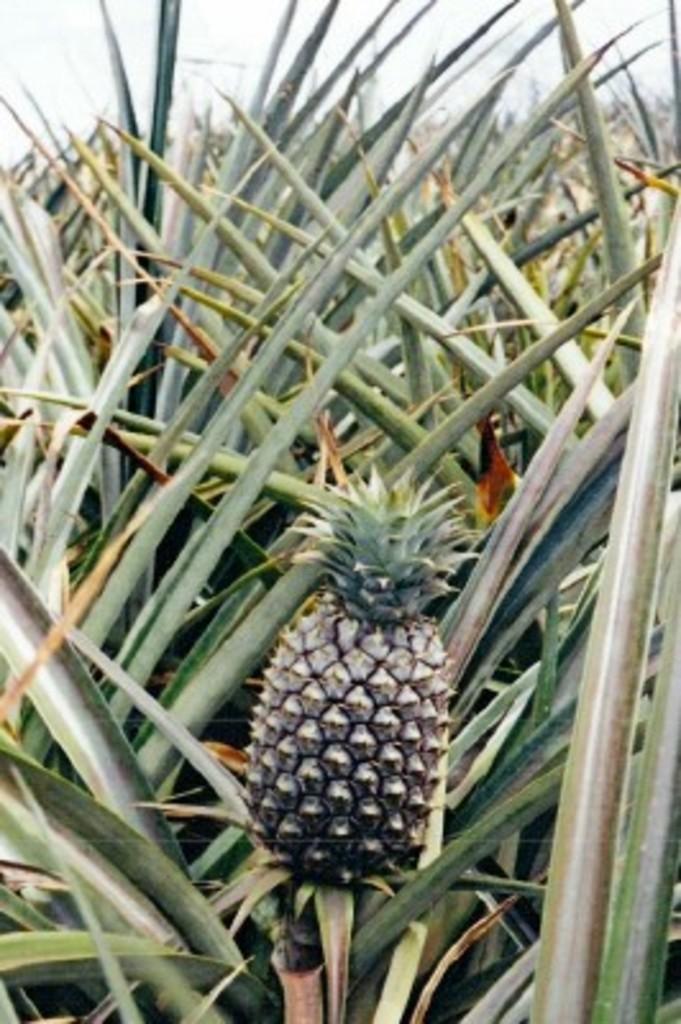Can you describe this image briefly? In this image I can see grass and I can see a pineapple visible on grass. 